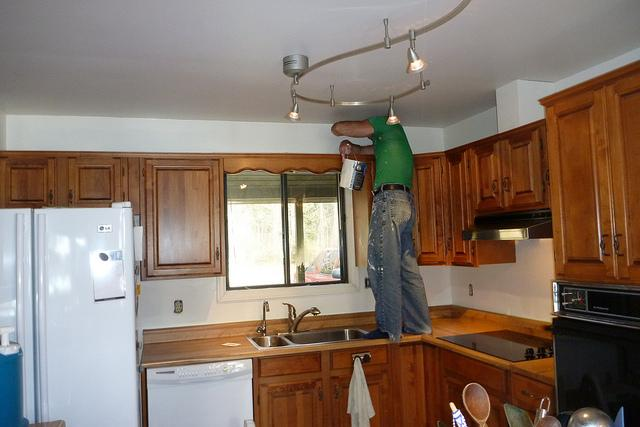Why is the man on the counter? painting 